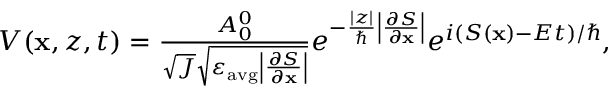<formula> <loc_0><loc_0><loc_500><loc_500>\begin{array} { r } { V ( x , z , t ) = \frac { A _ { 0 } ^ { 0 } } { \sqrt { J } \sqrt { \varepsilon _ { a v g } \left | \frac { \partial S } { \partial x } \right | } } e ^ { - \frac { | z | } { } \left | \frac { \partial S } { \partial x } \right | } e ^ { i ( S ( x ) - E t ) / } , } \end{array}</formula> 